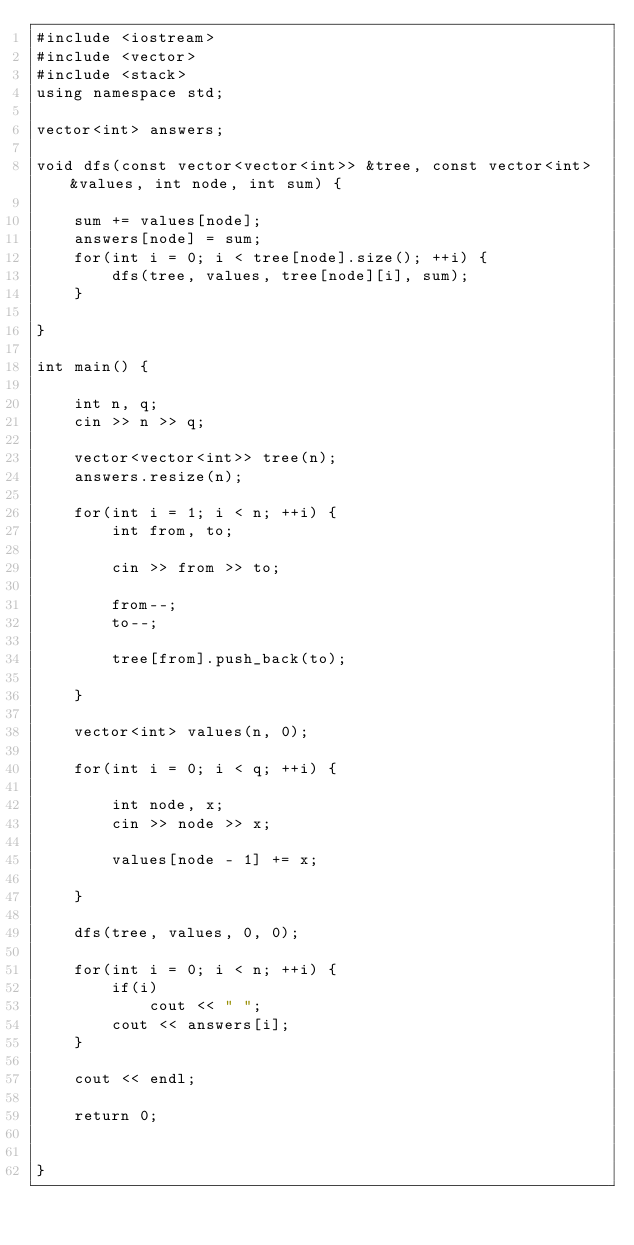<code> <loc_0><loc_0><loc_500><loc_500><_C++_>#include <iostream>
#include <vector>
#include <stack>
using namespace std;

vector<int> answers;

void dfs(const vector<vector<int>> &tree, const vector<int> &values, int node, int sum) {

    sum += values[node];
    answers[node] = sum;
    for(int i = 0; i < tree[node].size(); ++i) {
        dfs(tree, values, tree[node][i], sum);
    }

}

int main() {

    int n, q;
    cin >> n >> q;

    vector<vector<int>> tree(n);
    answers.resize(n);

    for(int i = 1; i < n; ++i) {
        int from, to;

        cin >> from >> to;

        from--;
        to--;
        
        tree[from].push_back(to);        

    }

    vector<int> values(n, 0);

    for(int i = 0; i < q; ++i) {

        int node, x;
        cin >> node >> x;

        values[node - 1] += x;

    }

    dfs(tree, values, 0, 0);

    for(int i = 0; i < n; ++i) {
        if(i)
            cout << " ";
        cout << answers[i];
    }

    cout << endl;

    return 0;


}</code> 